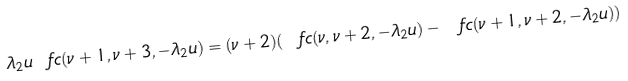Convert formula to latex. <formula><loc_0><loc_0><loc_500><loc_500>\lambda _ { 2 } u \ f c ( \nu + 1 , \nu + 3 , - \lambda _ { 2 } u ) = ( \nu + 2 ) ( \ f c ( \nu , \nu + 2 , - \lambda _ { 2 } u ) - \ f c ( \nu + 1 , \nu + 2 , - \lambda _ { 2 } u ) ) \\</formula> 